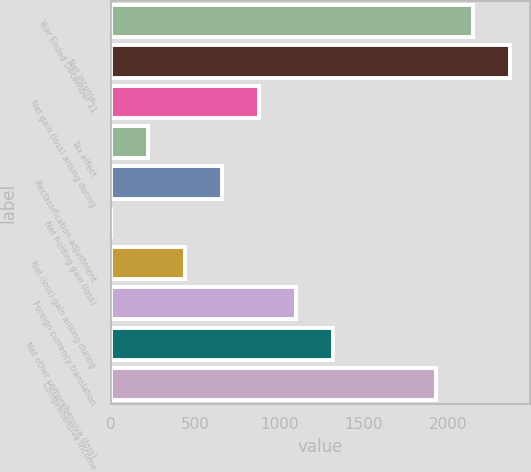<chart> <loc_0><loc_0><loc_500><loc_500><bar_chart><fcel>Year Ended December 31<fcel>Net income<fcel>Net gain (loss) arising during<fcel>Tax effect<fcel>Reclassification adjustment<fcel>Net holding gain (loss)<fcel>Net (loss) gain arising during<fcel>Foreign currency translation<fcel>Net other comprehensive (loss)<fcel>Comprehensive Income<nl><fcel>2142.89<fcel>2362.38<fcel>878.16<fcel>219.69<fcel>658.67<fcel>0.2<fcel>439.18<fcel>1097.65<fcel>1317.14<fcel>1923.4<nl></chart> 